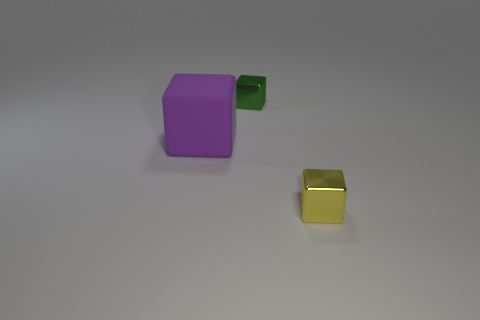Is there any other thing that is the same size as the purple rubber cube?
Make the answer very short. No. The big rubber object is what color?
Your answer should be compact. Purple. What color is the other metallic block that is the same size as the green shiny block?
Give a very brief answer. Yellow. How many metal objects are either large things or big green cylinders?
Make the answer very short. 0. What number of small cubes are on the right side of the tiny green metal block and behind the small yellow metal thing?
Provide a succinct answer. 0. How many other objects are the same size as the green object?
Offer a terse response. 1. There is a metal block that is behind the tiny yellow metallic object; is it the same size as the thing in front of the large purple object?
Offer a terse response. Yes. How many objects are purple rubber cubes or small cubes to the left of the yellow shiny object?
Provide a short and direct response. 2. There is a metallic cube that is left of the yellow block; what size is it?
Your answer should be compact. Small. Is the number of green objects to the left of the big rubber thing less than the number of purple rubber cubes that are in front of the small yellow metallic cube?
Your answer should be compact. No. 